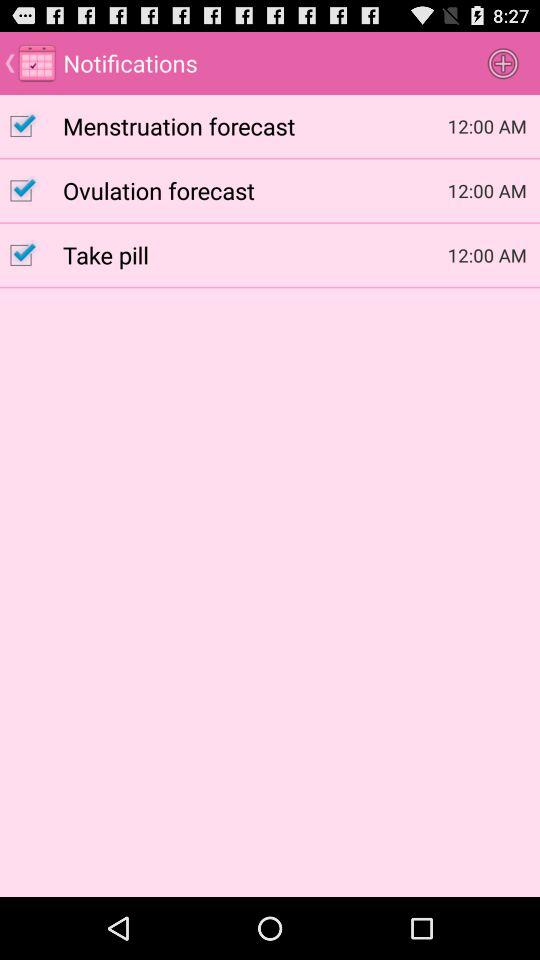What is the notification time of the Ovulation forecast? The notification time is 12:00 AM. 